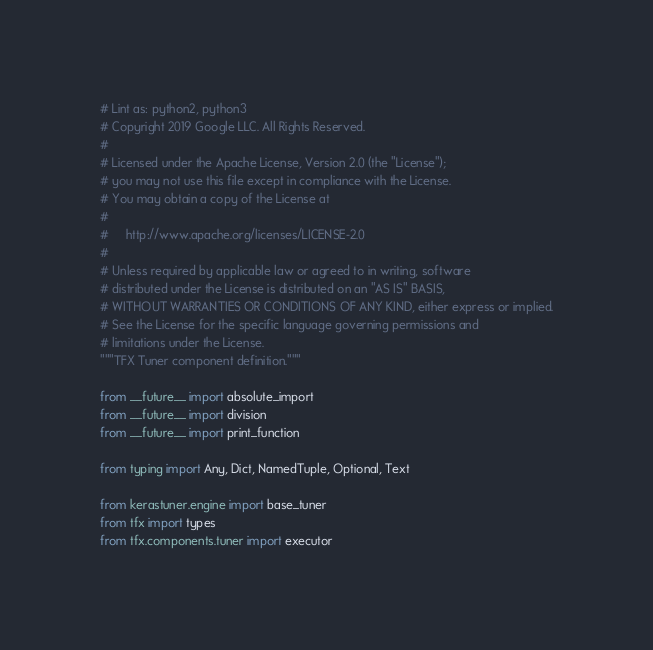Convert code to text. <code><loc_0><loc_0><loc_500><loc_500><_Python_># Lint as: python2, python3
# Copyright 2019 Google LLC. All Rights Reserved.
#
# Licensed under the Apache License, Version 2.0 (the "License");
# you may not use this file except in compliance with the License.
# You may obtain a copy of the License at
#
#     http://www.apache.org/licenses/LICENSE-2.0
#
# Unless required by applicable law or agreed to in writing, software
# distributed under the License is distributed on an "AS IS" BASIS,
# WITHOUT WARRANTIES OR CONDITIONS OF ANY KIND, either express or implied.
# See the License for the specific language governing permissions and
# limitations under the License.
"""TFX Tuner component definition."""

from __future__ import absolute_import
from __future__ import division
from __future__ import print_function

from typing import Any, Dict, NamedTuple, Optional, Text

from kerastuner.engine import base_tuner
from tfx import types
from tfx.components.tuner import executor</code> 